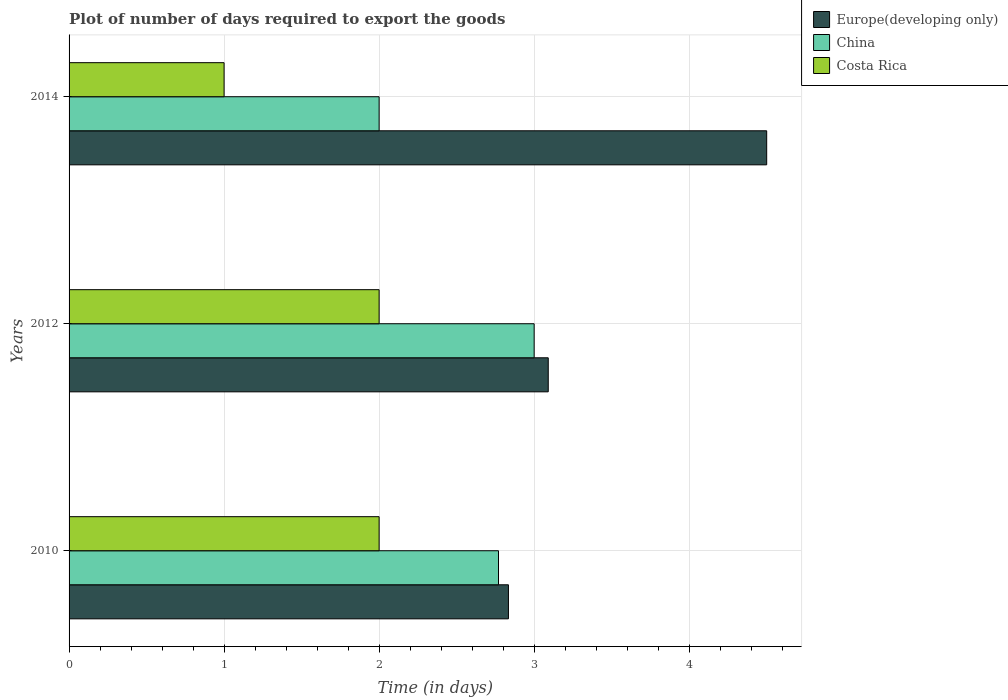How many groups of bars are there?
Offer a very short reply. 3. Are the number of bars per tick equal to the number of legend labels?
Offer a very short reply. Yes. How many bars are there on the 1st tick from the bottom?
Ensure brevity in your answer.  3. What is the time required to export goods in Europe(developing only) in 2010?
Your answer should be very brief. 2.83. Across all years, what is the minimum time required to export goods in Costa Rica?
Your response must be concise. 1. In which year was the time required to export goods in Europe(developing only) maximum?
Offer a terse response. 2014. In which year was the time required to export goods in China minimum?
Make the answer very short. 2014. What is the total time required to export goods in China in the graph?
Offer a terse response. 7.77. What is the difference between the time required to export goods in Europe(developing only) in 2012 and that in 2014?
Give a very brief answer. -1.41. What is the difference between the time required to export goods in Costa Rica in 2010 and the time required to export goods in Europe(developing only) in 2012?
Your response must be concise. -1.09. What is the average time required to export goods in China per year?
Make the answer very short. 2.59. In the year 2010, what is the difference between the time required to export goods in China and time required to export goods in Europe(developing only)?
Ensure brevity in your answer.  -0.06. In how many years, is the time required to export goods in Europe(developing only) greater than 3.2 days?
Provide a short and direct response. 1. Is the difference between the time required to export goods in China in 2012 and 2014 greater than the difference between the time required to export goods in Europe(developing only) in 2012 and 2014?
Make the answer very short. Yes. What is the difference between the highest and the second highest time required to export goods in Europe(developing only)?
Offer a terse response. 1.41. What is the difference between the highest and the lowest time required to export goods in Costa Rica?
Your response must be concise. 1. What does the 2nd bar from the bottom in 2012 represents?
Provide a short and direct response. China. Is it the case that in every year, the sum of the time required to export goods in Costa Rica and time required to export goods in Europe(developing only) is greater than the time required to export goods in China?
Provide a succinct answer. Yes. How many years are there in the graph?
Your answer should be very brief. 3. Are the values on the major ticks of X-axis written in scientific E-notation?
Your answer should be compact. No. Does the graph contain any zero values?
Provide a succinct answer. No. Does the graph contain grids?
Give a very brief answer. Yes. Where does the legend appear in the graph?
Give a very brief answer. Top right. What is the title of the graph?
Keep it short and to the point. Plot of number of days required to export the goods. What is the label or title of the X-axis?
Ensure brevity in your answer.  Time (in days). What is the Time (in days) of Europe(developing only) in 2010?
Your answer should be compact. 2.83. What is the Time (in days) in China in 2010?
Offer a very short reply. 2.77. What is the Time (in days) in Europe(developing only) in 2012?
Provide a succinct answer. 3.09. What is the Time (in days) of China in 2012?
Your response must be concise. 3. What is the Time (in days) in China in 2014?
Ensure brevity in your answer.  2. Across all years, what is the maximum Time (in days) of Europe(developing only)?
Your response must be concise. 4.5. Across all years, what is the maximum Time (in days) of China?
Provide a succinct answer. 3. Across all years, what is the minimum Time (in days) in Europe(developing only)?
Give a very brief answer. 2.83. What is the total Time (in days) in Europe(developing only) in the graph?
Keep it short and to the point. 10.43. What is the total Time (in days) of China in the graph?
Your response must be concise. 7.77. What is the difference between the Time (in days) in Europe(developing only) in 2010 and that in 2012?
Provide a succinct answer. -0.26. What is the difference between the Time (in days) in China in 2010 and that in 2012?
Keep it short and to the point. -0.23. What is the difference between the Time (in days) in Costa Rica in 2010 and that in 2012?
Your answer should be very brief. 0. What is the difference between the Time (in days) of Europe(developing only) in 2010 and that in 2014?
Offer a very short reply. -1.67. What is the difference between the Time (in days) in China in 2010 and that in 2014?
Your answer should be compact. 0.77. What is the difference between the Time (in days) in Europe(developing only) in 2012 and that in 2014?
Ensure brevity in your answer.  -1.41. What is the difference between the Time (in days) in China in 2012 and that in 2014?
Make the answer very short. 1. What is the difference between the Time (in days) in Europe(developing only) in 2010 and the Time (in days) in China in 2012?
Provide a succinct answer. -0.17. What is the difference between the Time (in days) in Europe(developing only) in 2010 and the Time (in days) in Costa Rica in 2012?
Ensure brevity in your answer.  0.83. What is the difference between the Time (in days) in China in 2010 and the Time (in days) in Costa Rica in 2012?
Provide a succinct answer. 0.77. What is the difference between the Time (in days) of Europe(developing only) in 2010 and the Time (in days) of China in 2014?
Ensure brevity in your answer.  0.83. What is the difference between the Time (in days) in Europe(developing only) in 2010 and the Time (in days) in Costa Rica in 2014?
Provide a short and direct response. 1.83. What is the difference between the Time (in days) of China in 2010 and the Time (in days) of Costa Rica in 2014?
Your answer should be compact. 1.77. What is the difference between the Time (in days) of Europe(developing only) in 2012 and the Time (in days) of Costa Rica in 2014?
Provide a succinct answer. 2.09. What is the difference between the Time (in days) in China in 2012 and the Time (in days) in Costa Rica in 2014?
Your answer should be compact. 2. What is the average Time (in days) of Europe(developing only) per year?
Give a very brief answer. 3.48. What is the average Time (in days) of China per year?
Your answer should be compact. 2.59. What is the average Time (in days) in Costa Rica per year?
Give a very brief answer. 1.67. In the year 2010, what is the difference between the Time (in days) in Europe(developing only) and Time (in days) in China?
Offer a terse response. 0.06. In the year 2010, what is the difference between the Time (in days) of Europe(developing only) and Time (in days) of Costa Rica?
Keep it short and to the point. 0.83. In the year 2010, what is the difference between the Time (in days) of China and Time (in days) of Costa Rica?
Provide a short and direct response. 0.77. In the year 2012, what is the difference between the Time (in days) of Europe(developing only) and Time (in days) of China?
Make the answer very short. 0.09. In the year 2012, what is the difference between the Time (in days) in China and Time (in days) in Costa Rica?
Offer a very short reply. 1. In the year 2014, what is the difference between the Time (in days) of Europe(developing only) and Time (in days) of Costa Rica?
Provide a succinct answer. 3.5. What is the ratio of the Time (in days) of Europe(developing only) in 2010 to that in 2012?
Provide a short and direct response. 0.92. What is the ratio of the Time (in days) in China in 2010 to that in 2012?
Your answer should be very brief. 0.92. What is the ratio of the Time (in days) of Costa Rica in 2010 to that in 2012?
Offer a terse response. 1. What is the ratio of the Time (in days) of Europe(developing only) in 2010 to that in 2014?
Make the answer very short. 0.63. What is the ratio of the Time (in days) in China in 2010 to that in 2014?
Keep it short and to the point. 1.39. What is the ratio of the Time (in days) of Costa Rica in 2010 to that in 2014?
Give a very brief answer. 2. What is the ratio of the Time (in days) in Europe(developing only) in 2012 to that in 2014?
Give a very brief answer. 0.69. What is the ratio of the Time (in days) of Costa Rica in 2012 to that in 2014?
Provide a succinct answer. 2. What is the difference between the highest and the second highest Time (in days) of Europe(developing only)?
Your response must be concise. 1.41. What is the difference between the highest and the second highest Time (in days) in China?
Keep it short and to the point. 0.23. What is the difference between the highest and the second highest Time (in days) of Costa Rica?
Provide a short and direct response. 0. What is the difference between the highest and the lowest Time (in days) in Europe(developing only)?
Ensure brevity in your answer.  1.67. What is the difference between the highest and the lowest Time (in days) of Costa Rica?
Your answer should be very brief. 1. 